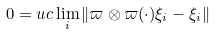Convert formula to latex. <formula><loc_0><loc_0><loc_500><loc_500>0 = u c \lim _ { i } \| \varpi \otimes \varpi ( \cdot ) \xi _ { i } - \xi _ { i } \|</formula> 